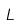Convert formula to latex. <formula><loc_0><loc_0><loc_500><loc_500>L</formula> 